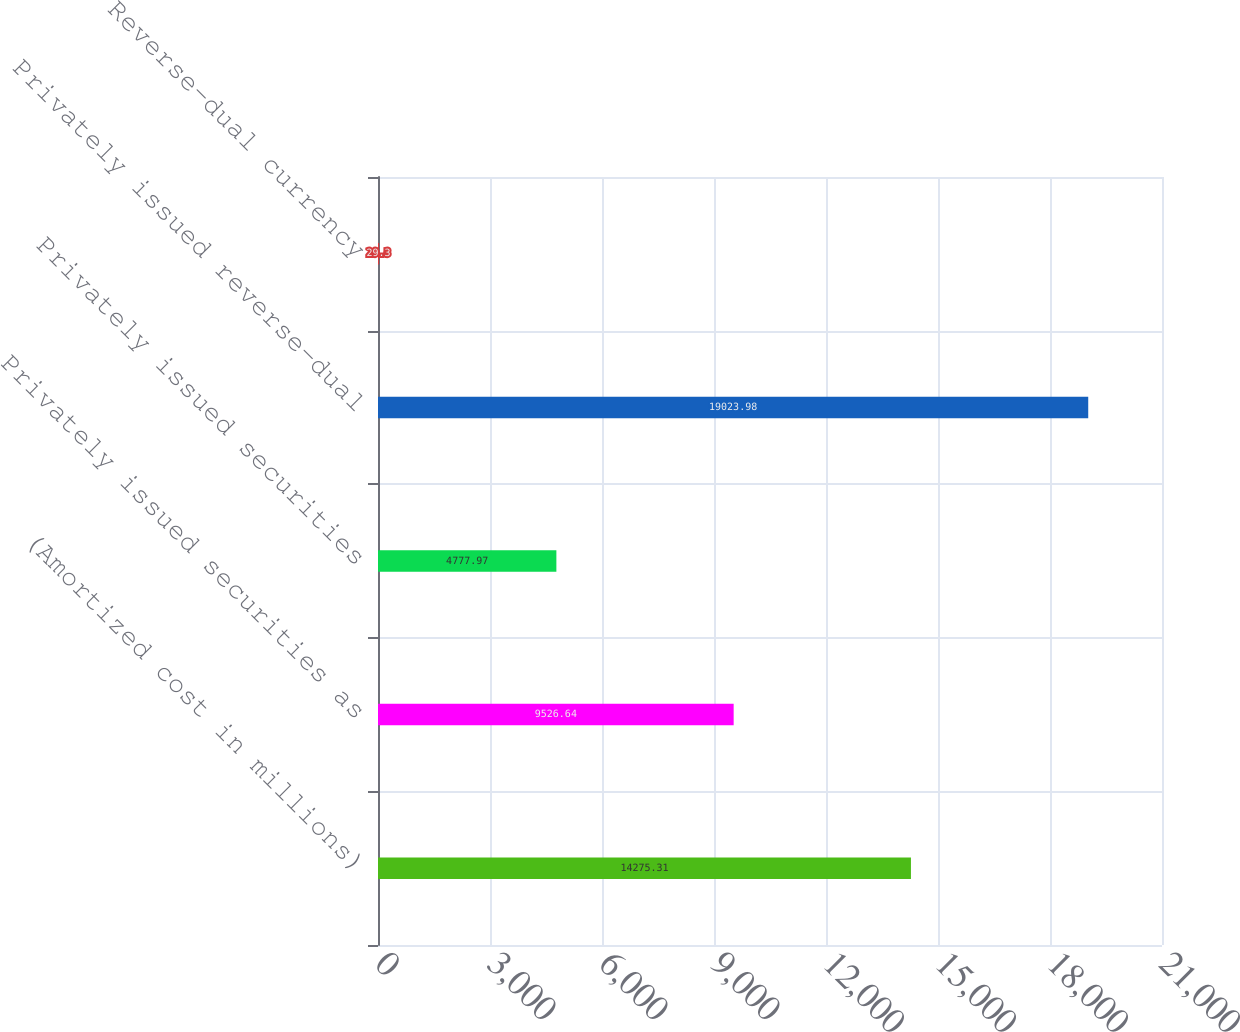Convert chart to OTSL. <chart><loc_0><loc_0><loc_500><loc_500><bar_chart><fcel>(Amortized cost in millions)<fcel>Privately issued securities as<fcel>Privately issued securities<fcel>Privately issued reverse-dual<fcel>Reverse-dual currency<nl><fcel>14275.3<fcel>9526.64<fcel>4777.97<fcel>19024<fcel>29.3<nl></chart> 